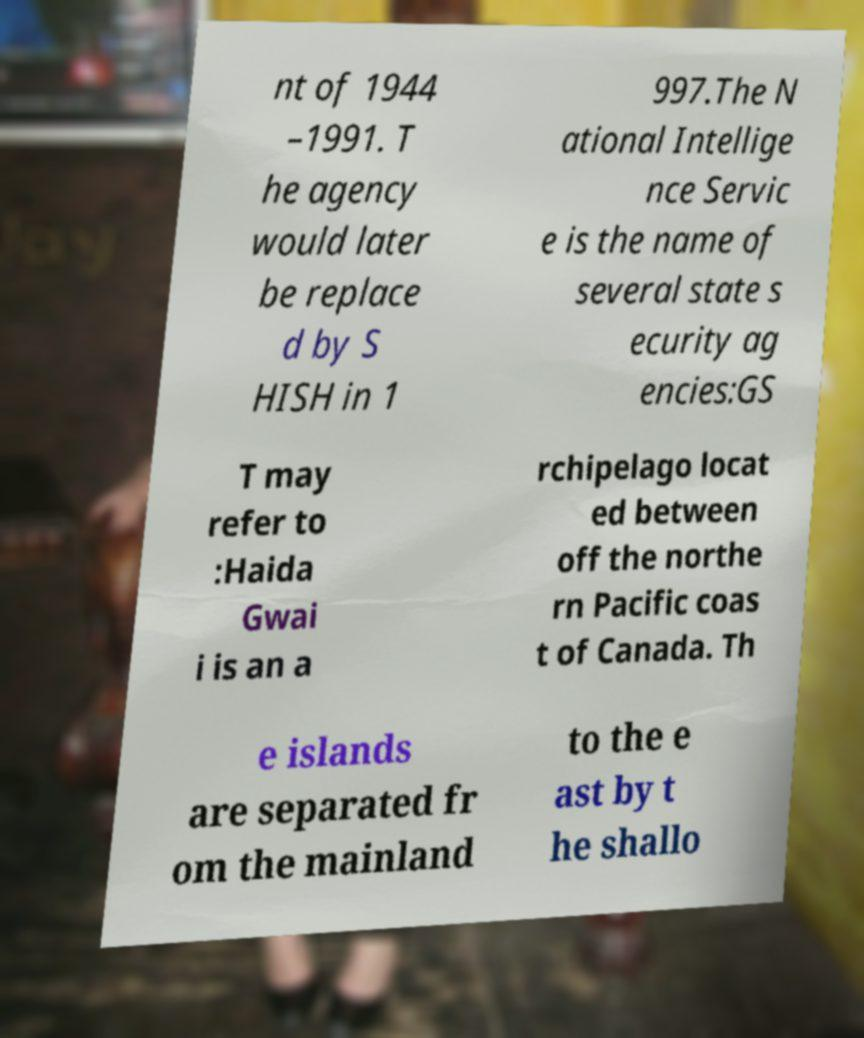Please identify and transcribe the text found in this image. nt of 1944 –1991. T he agency would later be replace d by S HISH in 1 997.The N ational Intellige nce Servic e is the name of several state s ecurity ag encies:GS T may refer to :Haida Gwai i is an a rchipelago locat ed between off the northe rn Pacific coas t of Canada. Th e islands are separated fr om the mainland to the e ast by t he shallo 